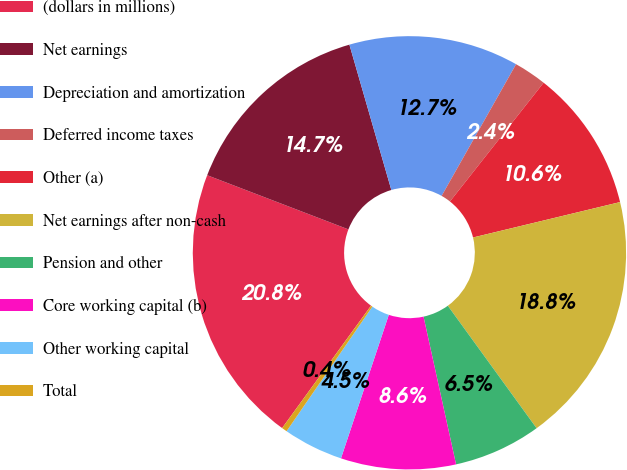Convert chart to OTSL. <chart><loc_0><loc_0><loc_500><loc_500><pie_chart><fcel>(dollars in millions)<fcel>Net earnings<fcel>Depreciation and amortization<fcel>Deferred income taxes<fcel>Other (a)<fcel>Net earnings after non-cash<fcel>Pension and other<fcel>Core working capital (b)<fcel>Other working capital<fcel>Total<nl><fcel>20.83%<fcel>14.7%<fcel>12.66%<fcel>2.44%<fcel>10.61%<fcel>18.78%<fcel>6.53%<fcel>8.57%<fcel>4.48%<fcel>0.4%<nl></chart> 